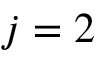<formula> <loc_0><loc_0><loc_500><loc_500>j = 2</formula> 